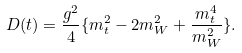<formula> <loc_0><loc_0><loc_500><loc_500>D ( t ) = \frac { g ^ { 2 } } { 4 } \{ m _ { t } ^ { 2 } - 2 m _ { W } ^ { 2 } + \frac { m _ { t } ^ { 4 } } { m _ { W } ^ { 2 } } \} .</formula> 